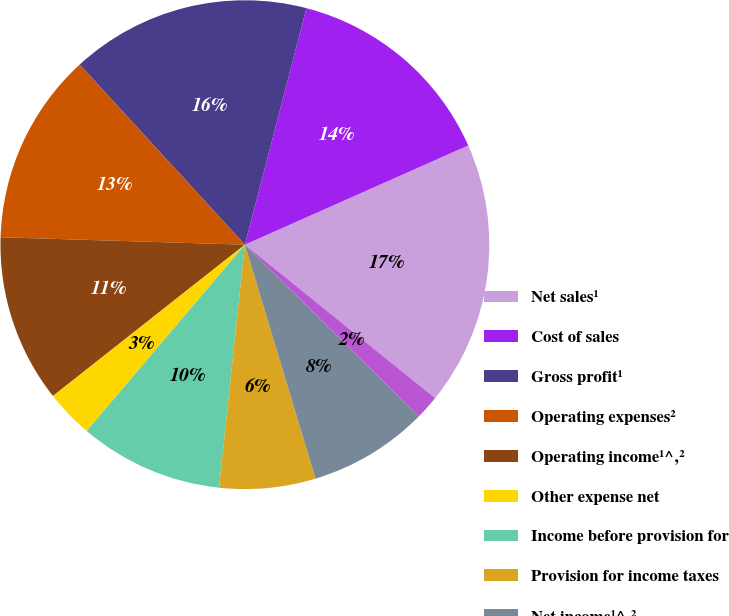Convert chart to OTSL. <chart><loc_0><loc_0><loc_500><loc_500><pie_chart><fcel>Net sales¹<fcel>Cost of sales<fcel>Gross profit¹<fcel>Operating expenses²<fcel>Operating income¹^‚²<fcel>Other expense net<fcel>Income before provision for<fcel>Provision for income taxes<fcel>Net income¹^‚²<fcel>Basic<nl><fcel>17.46%<fcel>14.29%<fcel>15.87%<fcel>12.7%<fcel>11.11%<fcel>3.17%<fcel>9.52%<fcel>6.35%<fcel>7.94%<fcel>1.59%<nl></chart> 